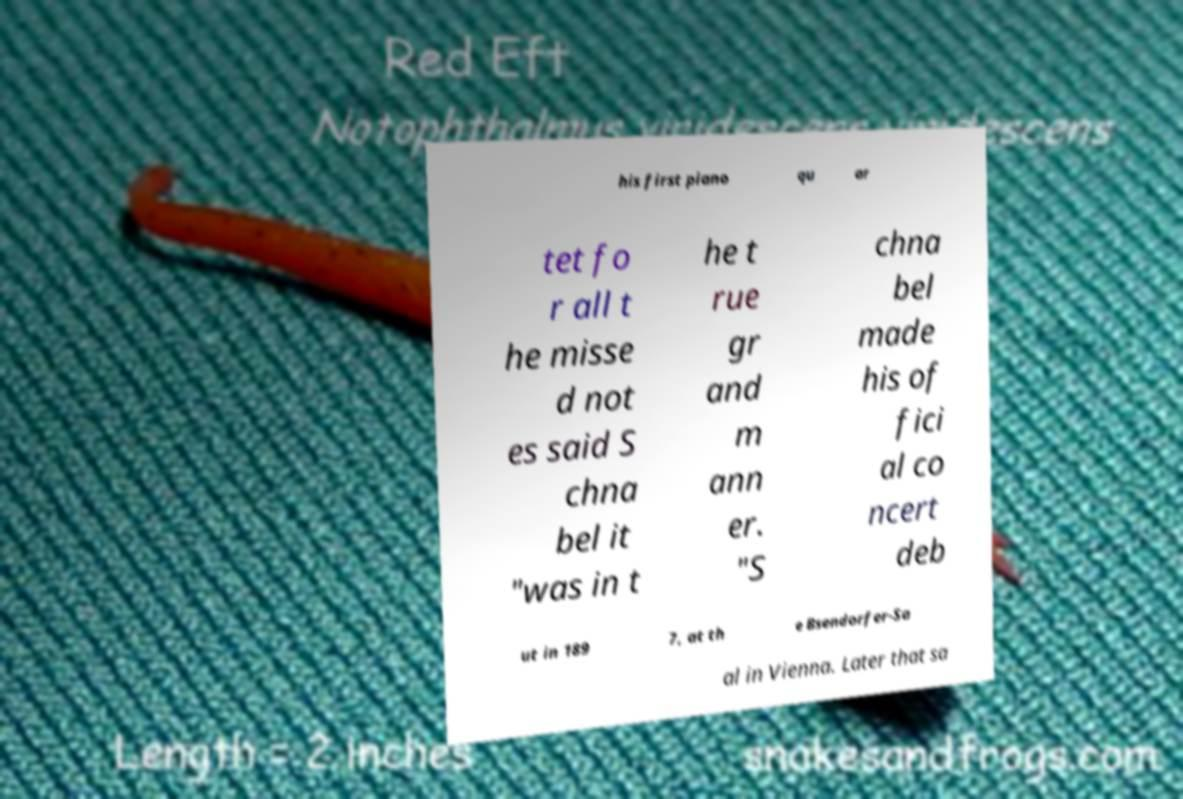Can you read and provide the text displayed in the image?This photo seems to have some interesting text. Can you extract and type it out for me? his first piano qu ar tet fo r all t he misse d not es said S chna bel it "was in t he t rue gr and m ann er. "S chna bel made his of fici al co ncert deb ut in 189 7, at th e Bsendorfer-Sa al in Vienna. Later that sa 